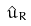<formula> <loc_0><loc_0><loc_500><loc_500>\hat { u } _ { R }</formula> 